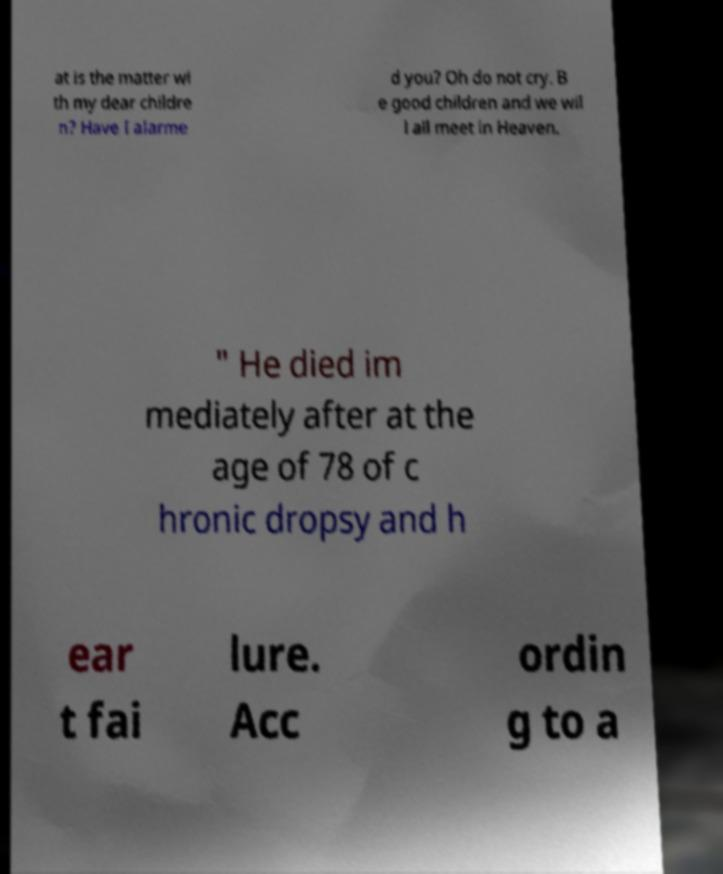Could you extract and type out the text from this image? at is the matter wi th my dear childre n? Have I alarme d you? Oh do not cry. B e good children and we wil l all meet in Heaven. " He died im mediately after at the age of 78 of c hronic dropsy and h ear t fai lure. Acc ordin g to a 